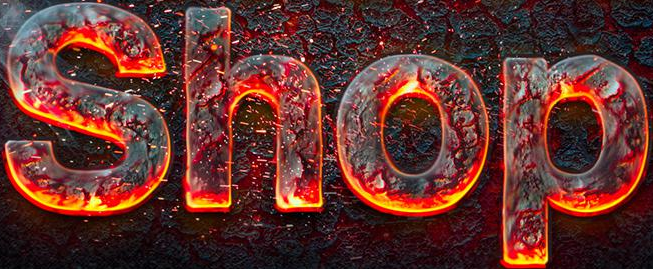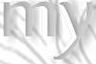What words are shown in these images in order, separated by a semicolon? Shop; my 